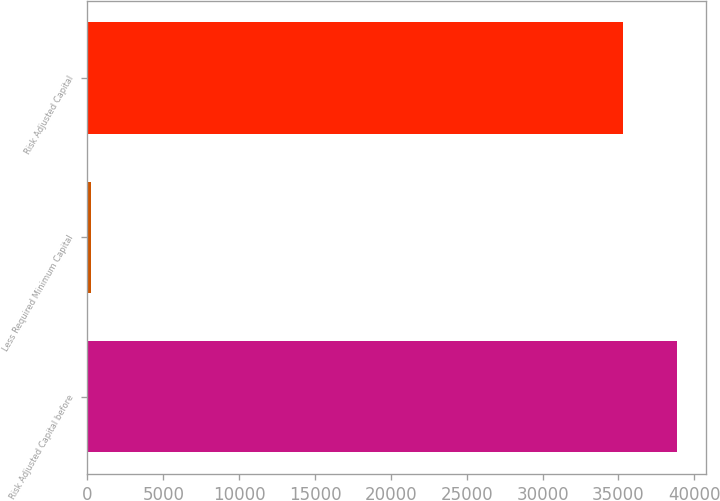<chart> <loc_0><loc_0><loc_500><loc_500><bar_chart><fcel>Risk Adjusted Capital before<fcel>Less Required Minimum Capital<fcel>Risk Adjusted Capital<nl><fcel>38857.5<fcel>250<fcel>35325<nl></chart> 